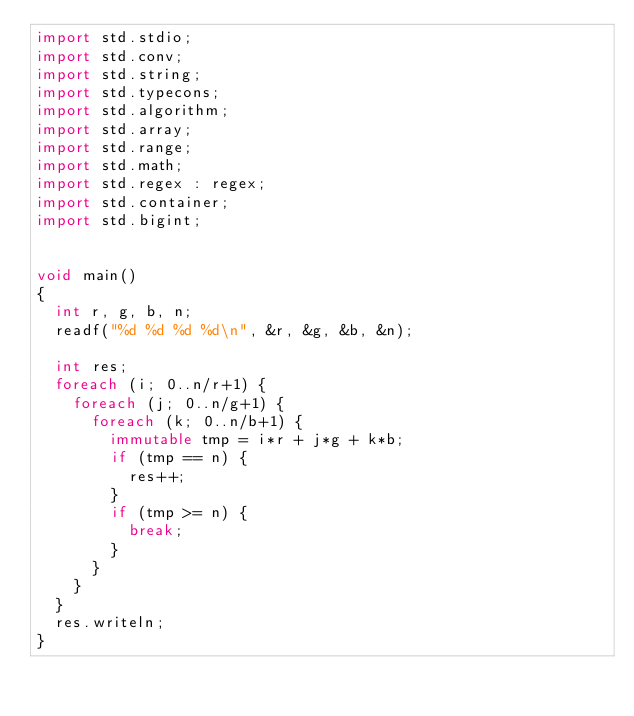Convert code to text. <code><loc_0><loc_0><loc_500><loc_500><_D_>import std.stdio;
import std.conv;
import std.string;
import std.typecons;
import std.algorithm;
import std.array;
import std.range;
import std.math;
import std.regex : regex;
import std.container;
import std.bigint;


void main()
{
  int r, g, b, n;
  readf("%d %d %d %d\n", &r, &g, &b, &n);
  
  int res;
  foreach (i; 0..n/r+1) {
    foreach (j; 0..n/g+1) {
      foreach (k; 0..n/b+1) {
        immutable tmp = i*r + j*g + k*b;
        if (tmp == n) {
          res++;
        }
        if (tmp >= n) {
          break;
        }
      }
    }
  }
  res.writeln;
}
</code> 